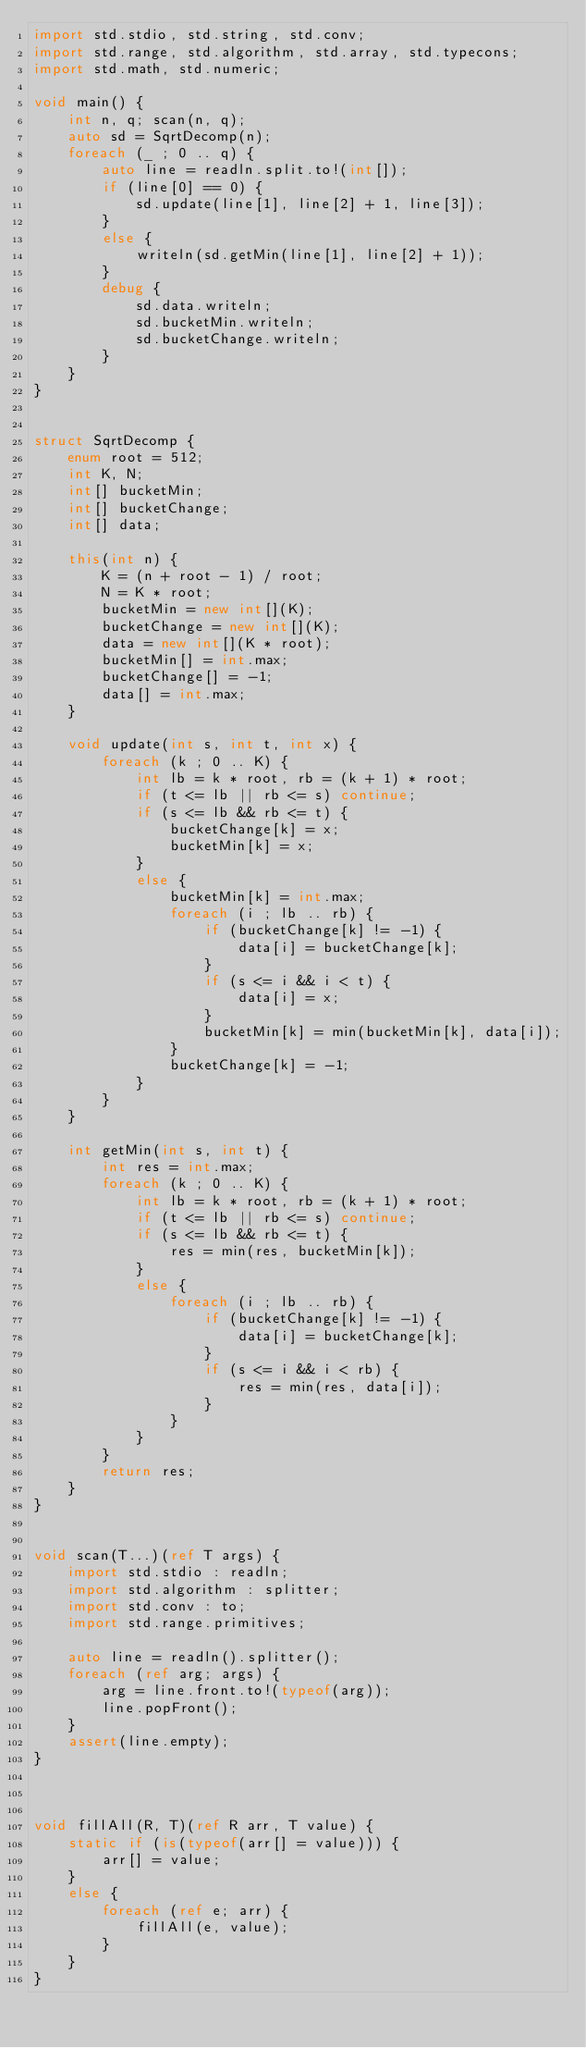Convert code to text. <code><loc_0><loc_0><loc_500><loc_500><_D_>import std.stdio, std.string, std.conv;
import std.range, std.algorithm, std.array, std.typecons;
import std.math, std.numeric;

void main() {
    int n, q; scan(n, q);
    auto sd = SqrtDecomp(n);
    foreach (_ ; 0 .. q) {
        auto line = readln.split.to!(int[]);
        if (line[0] == 0) {
            sd.update(line[1], line[2] + 1, line[3]);
        }
        else {
            writeln(sd.getMin(line[1], line[2] + 1));
        }
        debug {
            sd.data.writeln;
            sd.bucketMin.writeln;
            sd.bucketChange.writeln;
        }
    }
}


struct SqrtDecomp {
    enum root = 512;
    int K, N;
    int[] bucketMin;
    int[] bucketChange;
    int[] data;

    this(int n) {
        K = (n + root - 1) / root;
        N = K * root;
        bucketMin = new int[](K);
        bucketChange = new int[](K);
        data = new int[](K * root);
        bucketMin[] = int.max;
        bucketChange[] = -1;
        data[] = int.max;
    }

    void update(int s, int t, int x) {
        foreach (k ; 0 .. K) {
            int lb = k * root, rb = (k + 1) * root;
            if (t <= lb || rb <= s) continue;
            if (s <= lb && rb <= t) {
                bucketChange[k] = x;
                bucketMin[k] = x;
            }
            else {
                bucketMin[k] = int.max;
                foreach (i ; lb .. rb) {
                    if (bucketChange[k] != -1) {
                        data[i] = bucketChange[k];
                    }
                    if (s <= i && i < t) {
                        data[i] = x;
                    }
                    bucketMin[k] = min(bucketMin[k], data[i]);
                }
                bucketChange[k] = -1;
            }
        }
    }

    int getMin(int s, int t) {
        int res = int.max;
        foreach (k ; 0 .. K) {
            int lb = k * root, rb = (k + 1) * root;
            if (t <= lb || rb <= s) continue;
            if (s <= lb && rb <= t) {
                res = min(res, bucketMin[k]);
            }
            else {
                foreach (i ; lb .. rb) {
                    if (bucketChange[k] != -1) {
                        data[i] = bucketChange[k];
                    }
                    if (s <= i && i < rb) {
                        res = min(res, data[i]);
                    }
                }
            }
        }
        return res;
    }
}


void scan(T...)(ref T args) {
    import std.stdio : readln;
    import std.algorithm : splitter;
    import std.conv : to;
    import std.range.primitives;

    auto line = readln().splitter();
    foreach (ref arg; args) {
        arg = line.front.to!(typeof(arg));
        line.popFront();
    }
    assert(line.empty);
}



void fillAll(R, T)(ref R arr, T value) {
    static if (is(typeof(arr[] = value))) {
        arr[] = value;
    }
    else {
        foreach (ref e; arr) {
            fillAll(e, value);
        }
    }
}

</code> 